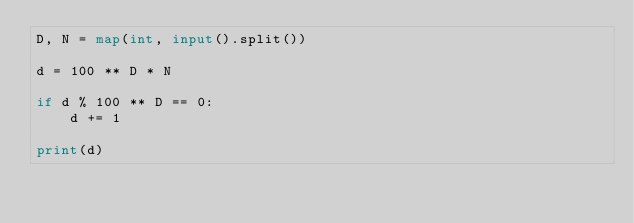<code> <loc_0><loc_0><loc_500><loc_500><_Python_>D, N = map(int, input().split())

d = 100 ** D * N

if d % 100 ** D == 0:
    d += 1

print(d)
</code> 